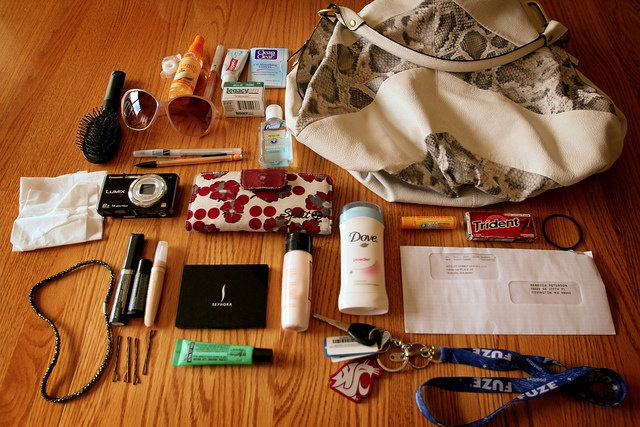Describe the objects in this image and their specific colors. I can see dining table in brown, maroon, black, and tan tones, handbag in brown, maroon, gray, and tan tones, and handbag in brown, maroon, tan, and black tones in this image. 